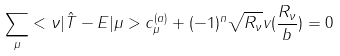<formula> <loc_0><loc_0><loc_500><loc_500>\sum _ { \mu } < \nu | \hat { T } - E | \mu > c _ { \mu } ^ { ( a ) } + ( - 1 ) ^ { n } \sqrt { R _ { \nu } } v ( \frac { R _ { \nu } } { b } ) = 0</formula> 